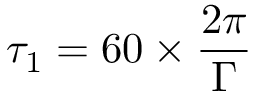<formula> <loc_0><loc_0><loc_500><loc_500>\tau _ { 1 } = 6 0 \times \frac { 2 \pi } { \Gamma }</formula> 